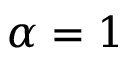<formula> <loc_0><loc_0><loc_500><loc_500>\alpha = 1</formula> 